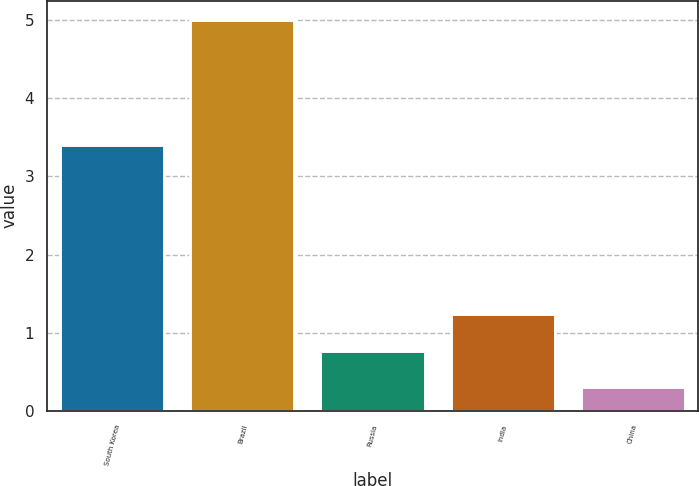<chart> <loc_0><loc_0><loc_500><loc_500><bar_chart><fcel>South Korea<fcel>Brazil<fcel>Russia<fcel>India<fcel>China<nl><fcel>3.4<fcel>5<fcel>0.77<fcel>1.24<fcel>0.3<nl></chart> 